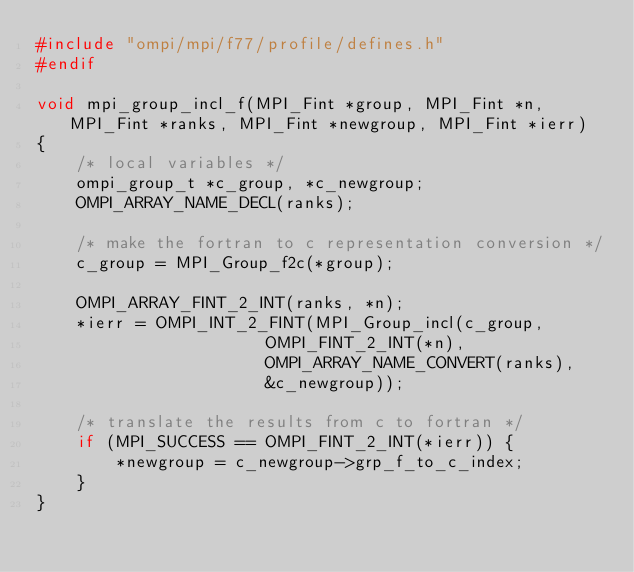Convert code to text. <code><loc_0><loc_0><loc_500><loc_500><_C_>#include "ompi/mpi/f77/profile/defines.h"
#endif

void mpi_group_incl_f(MPI_Fint *group, MPI_Fint *n, MPI_Fint *ranks, MPI_Fint *newgroup, MPI_Fint *ierr)
{
    /* local variables */
    ompi_group_t *c_group, *c_newgroup;
    OMPI_ARRAY_NAME_DECL(ranks);
  
    /* make the fortran to c representation conversion */
    c_group = MPI_Group_f2c(*group);

    OMPI_ARRAY_FINT_2_INT(ranks, *n);
    *ierr = OMPI_INT_2_FINT(MPI_Group_incl(c_group, 
					   OMPI_FINT_2_INT(*n),
					   OMPI_ARRAY_NAME_CONVERT(ranks),
					   &c_newgroup));

    /* translate the results from c to fortran */
    if (MPI_SUCCESS == OMPI_FINT_2_INT(*ierr)) {
        *newgroup = c_newgroup->grp_f_to_c_index;
    }
}
</code> 